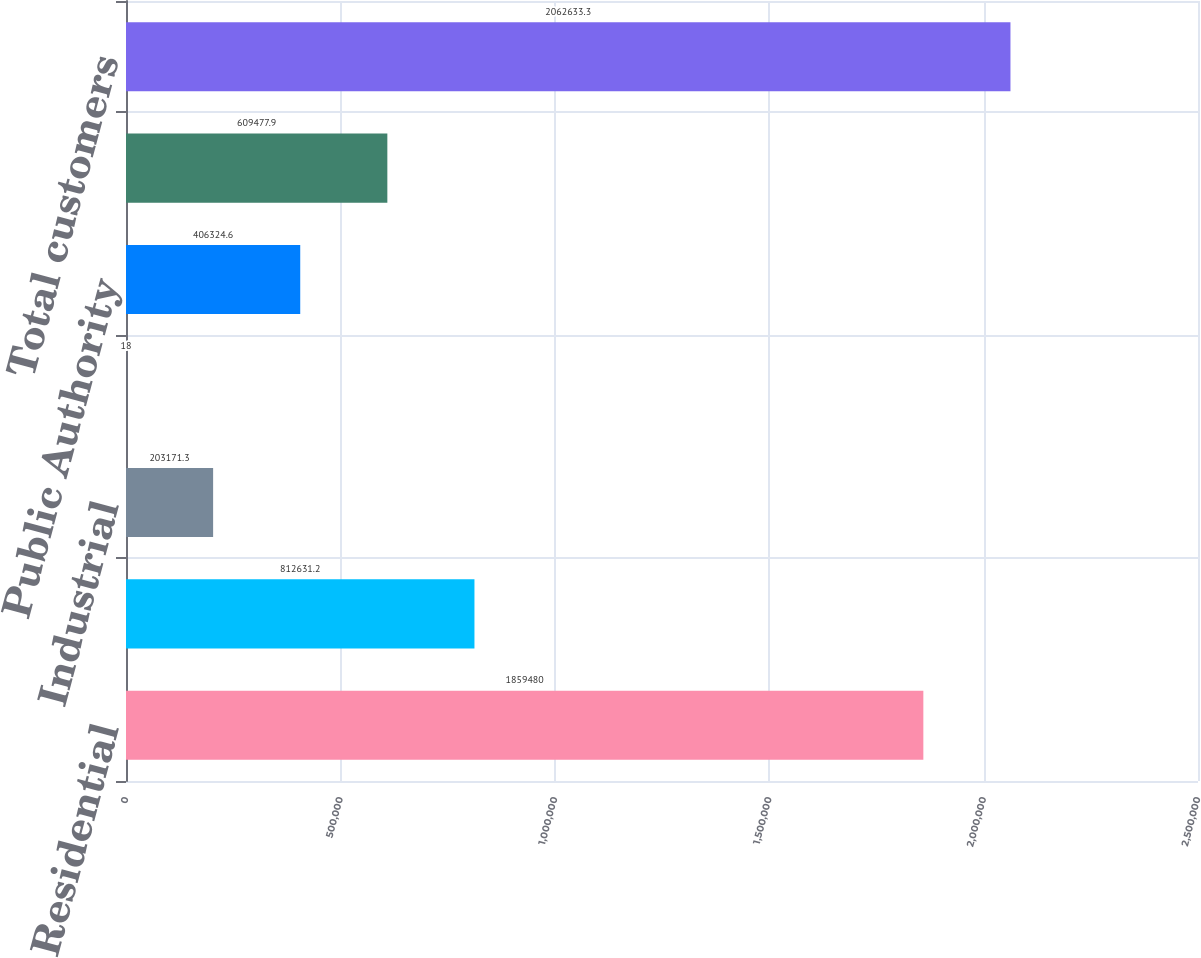Convert chart. <chart><loc_0><loc_0><loc_500><loc_500><bar_chart><fcel>Residential<fcel>Commercial<fcel>Industrial<fcel>Wholesale<fcel>Public Authority<fcel>Transportation<fcel>Total customers<nl><fcel>1.85948e+06<fcel>812631<fcel>203171<fcel>18<fcel>406325<fcel>609478<fcel>2.06263e+06<nl></chart> 